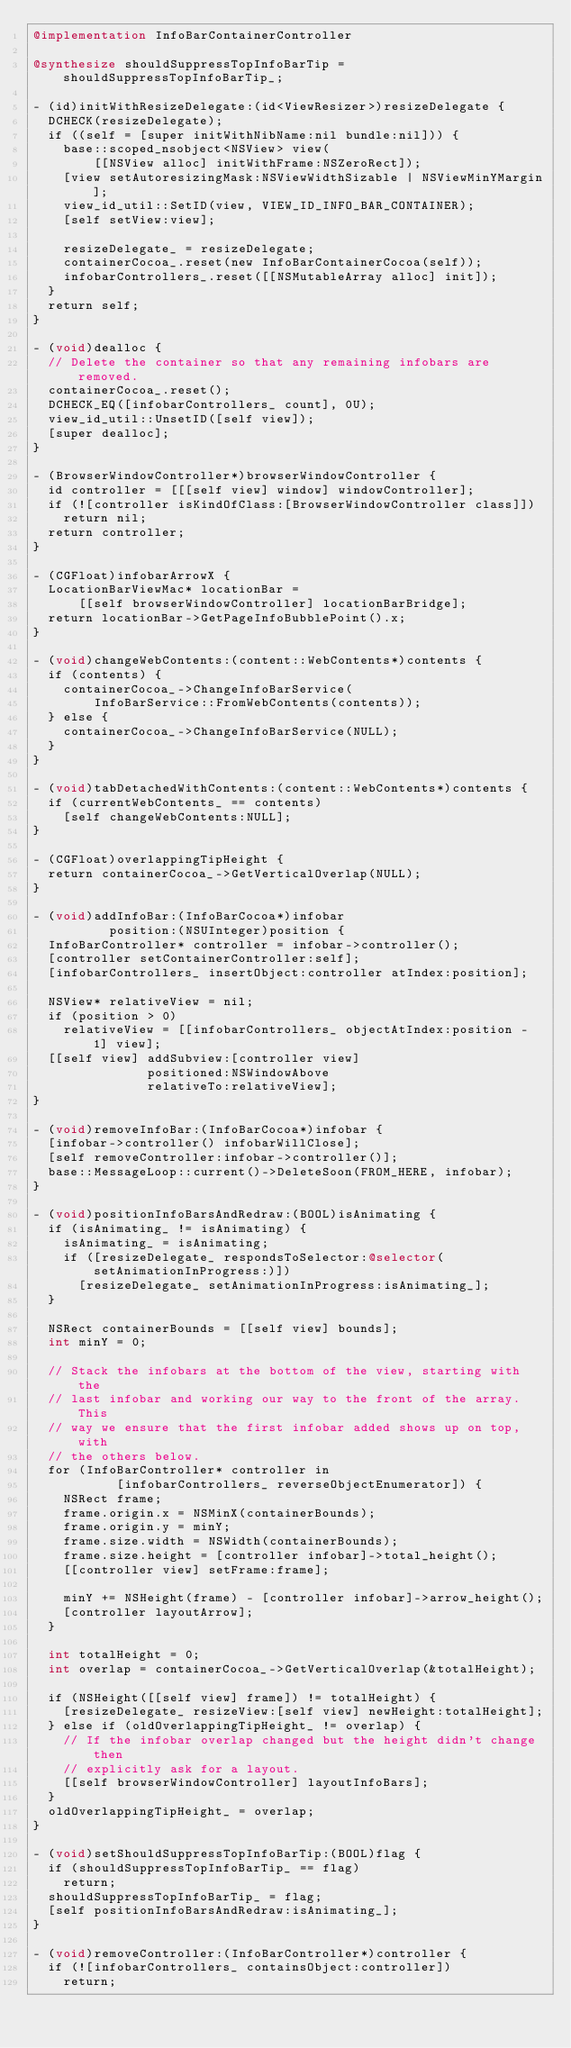Convert code to text. <code><loc_0><loc_0><loc_500><loc_500><_ObjectiveC_>@implementation InfoBarContainerController

@synthesize shouldSuppressTopInfoBarTip = shouldSuppressTopInfoBarTip_;

- (id)initWithResizeDelegate:(id<ViewResizer>)resizeDelegate {
  DCHECK(resizeDelegate);
  if ((self = [super initWithNibName:nil bundle:nil])) {
    base::scoped_nsobject<NSView> view(
        [[NSView alloc] initWithFrame:NSZeroRect]);
    [view setAutoresizingMask:NSViewWidthSizable | NSViewMinYMargin];
    view_id_util::SetID(view, VIEW_ID_INFO_BAR_CONTAINER);
    [self setView:view];

    resizeDelegate_ = resizeDelegate;
    containerCocoa_.reset(new InfoBarContainerCocoa(self));
    infobarControllers_.reset([[NSMutableArray alloc] init]);
  }
  return self;
}

- (void)dealloc {
  // Delete the container so that any remaining infobars are removed.
  containerCocoa_.reset();
  DCHECK_EQ([infobarControllers_ count], 0U);
  view_id_util::UnsetID([self view]);
  [super dealloc];
}

- (BrowserWindowController*)browserWindowController {
  id controller = [[[self view] window] windowController];
  if (![controller isKindOfClass:[BrowserWindowController class]])
    return nil;
  return controller;
}

- (CGFloat)infobarArrowX {
  LocationBarViewMac* locationBar =
      [[self browserWindowController] locationBarBridge];
  return locationBar->GetPageInfoBubblePoint().x;
}

- (void)changeWebContents:(content::WebContents*)contents {
  if (contents) {
    containerCocoa_->ChangeInfoBarService(
        InfoBarService::FromWebContents(contents));
  } else {
    containerCocoa_->ChangeInfoBarService(NULL);
  }
}

- (void)tabDetachedWithContents:(content::WebContents*)contents {
  if (currentWebContents_ == contents)
    [self changeWebContents:NULL];
}

- (CGFloat)overlappingTipHeight {
  return containerCocoa_->GetVerticalOverlap(NULL);
}

- (void)addInfoBar:(InfoBarCocoa*)infobar
          position:(NSUInteger)position {
  InfoBarController* controller = infobar->controller();
  [controller setContainerController:self];
  [infobarControllers_ insertObject:controller atIndex:position];

  NSView* relativeView = nil;
  if (position > 0)
    relativeView = [[infobarControllers_ objectAtIndex:position - 1] view];
  [[self view] addSubview:[controller view]
               positioned:NSWindowAbove
               relativeTo:relativeView];
}

- (void)removeInfoBar:(InfoBarCocoa*)infobar {
  [infobar->controller() infobarWillClose];
  [self removeController:infobar->controller()];
  base::MessageLoop::current()->DeleteSoon(FROM_HERE, infobar);
}

- (void)positionInfoBarsAndRedraw:(BOOL)isAnimating {
  if (isAnimating_ != isAnimating) {
    isAnimating_ = isAnimating;
    if ([resizeDelegate_ respondsToSelector:@selector(setAnimationInProgress:)])
      [resizeDelegate_ setAnimationInProgress:isAnimating_];
  }

  NSRect containerBounds = [[self view] bounds];
  int minY = 0;

  // Stack the infobars at the bottom of the view, starting with the
  // last infobar and working our way to the front of the array.  This
  // way we ensure that the first infobar added shows up on top, with
  // the others below.
  for (InfoBarController* controller in
           [infobarControllers_ reverseObjectEnumerator]) {
    NSRect frame;
    frame.origin.x = NSMinX(containerBounds);
    frame.origin.y = minY;
    frame.size.width = NSWidth(containerBounds);
    frame.size.height = [controller infobar]->total_height();
    [[controller view] setFrame:frame];

    minY += NSHeight(frame) - [controller infobar]->arrow_height();
    [controller layoutArrow];
  }

  int totalHeight = 0;
  int overlap = containerCocoa_->GetVerticalOverlap(&totalHeight);

  if (NSHeight([[self view] frame]) != totalHeight) {
    [resizeDelegate_ resizeView:[self view] newHeight:totalHeight];
  } else if (oldOverlappingTipHeight_ != overlap) {
    // If the infobar overlap changed but the height didn't change then
    // explicitly ask for a layout.
    [[self browserWindowController] layoutInfoBars];
  }
  oldOverlappingTipHeight_ = overlap;
}

- (void)setShouldSuppressTopInfoBarTip:(BOOL)flag {
  if (shouldSuppressTopInfoBarTip_ == flag)
    return;
  shouldSuppressTopInfoBarTip_ = flag;
  [self positionInfoBarsAndRedraw:isAnimating_];
}

- (void)removeController:(InfoBarController*)controller {
  if (![infobarControllers_ containsObject:controller])
    return;
</code> 